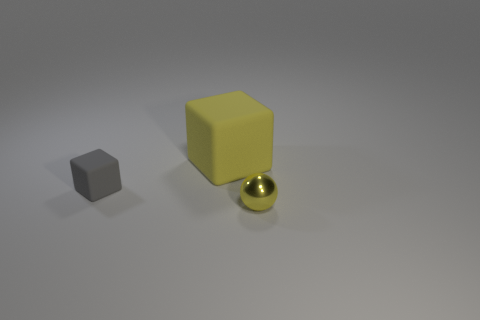Add 3 big blue cylinders. How many objects exist? 6 Subtract all cubes. How many objects are left? 1 Add 1 cubes. How many cubes exist? 3 Subtract 0 green blocks. How many objects are left? 3 Subtract all yellow metal spheres. Subtract all tiny things. How many objects are left? 0 Add 2 yellow matte things. How many yellow matte things are left? 3 